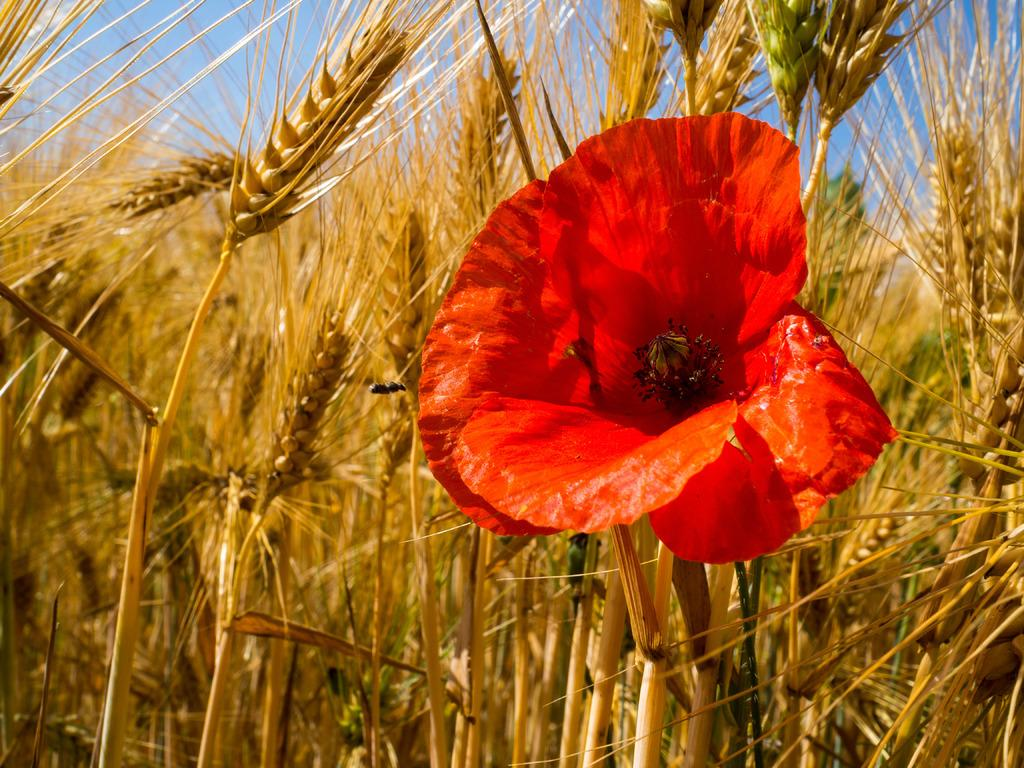What type of plant can be seen in the image? There is a flower in the image. What is the primary setting in which the flower is situated? There is a wheat field in the image. What is visible in the background of the image? The sky is visible in the background of the image. Is there a visitor holding an umbrella near the sea in the image? There is no visitor holding an umbrella near the sea in the image, as the image features a flower in a wheat field with a visible sky in the background. 